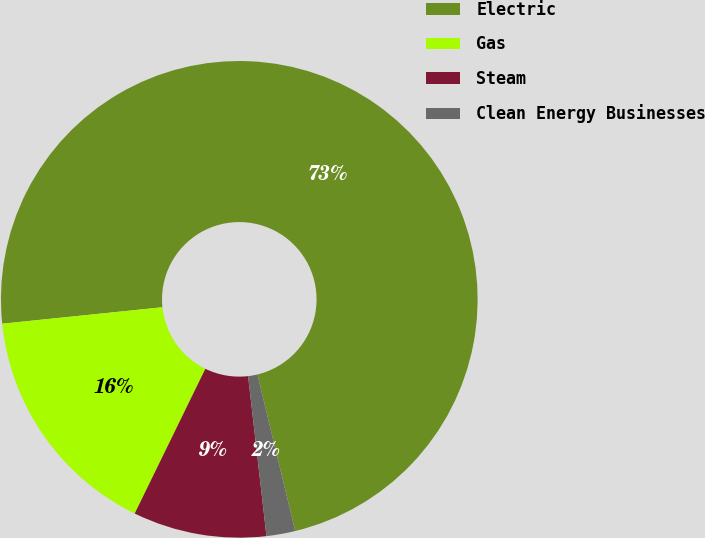Convert chart to OTSL. <chart><loc_0><loc_0><loc_500><loc_500><pie_chart><fcel>Electric<fcel>Gas<fcel>Steam<fcel>Clean Energy Businesses<nl><fcel>72.86%<fcel>16.14%<fcel>9.05%<fcel>1.95%<nl></chart> 